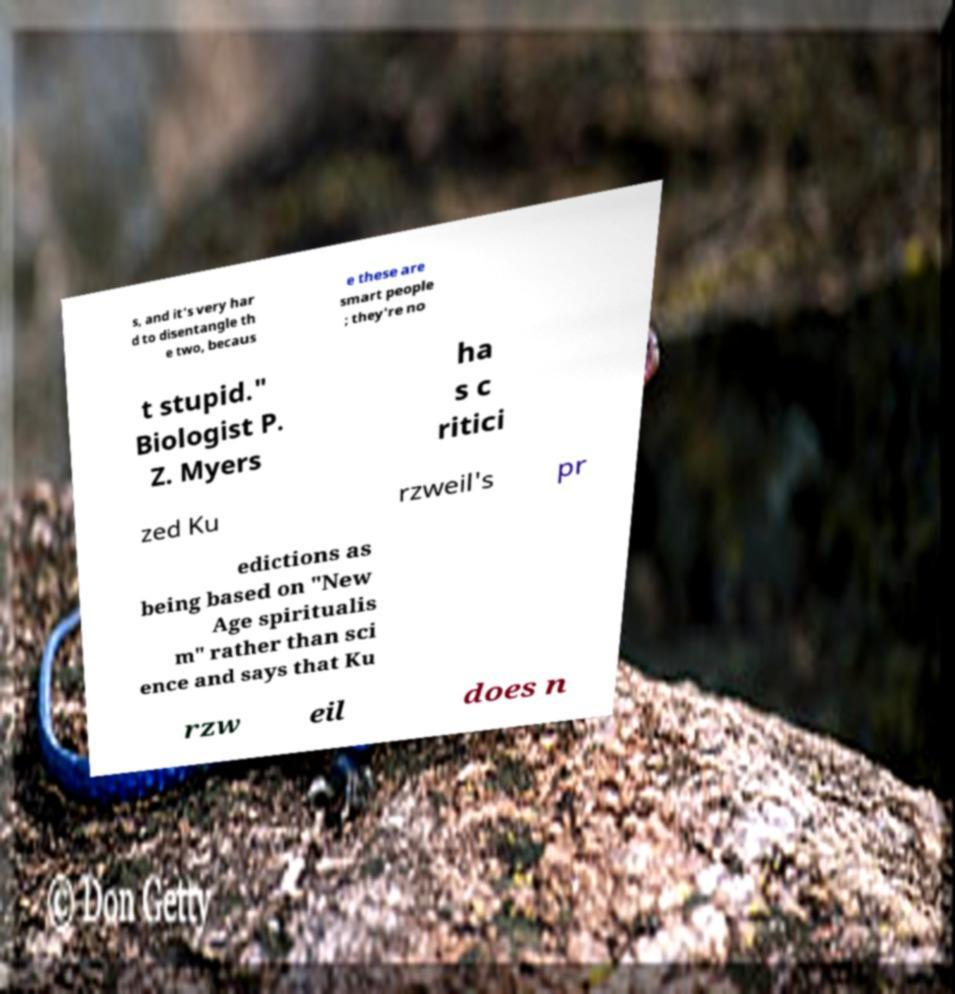Could you assist in decoding the text presented in this image and type it out clearly? s, and it's very har d to disentangle th e two, becaus e these are smart people ; they're no t stupid." Biologist P. Z. Myers ha s c ritici zed Ku rzweil's pr edictions as being based on "New Age spiritualis m" rather than sci ence and says that Ku rzw eil does n 